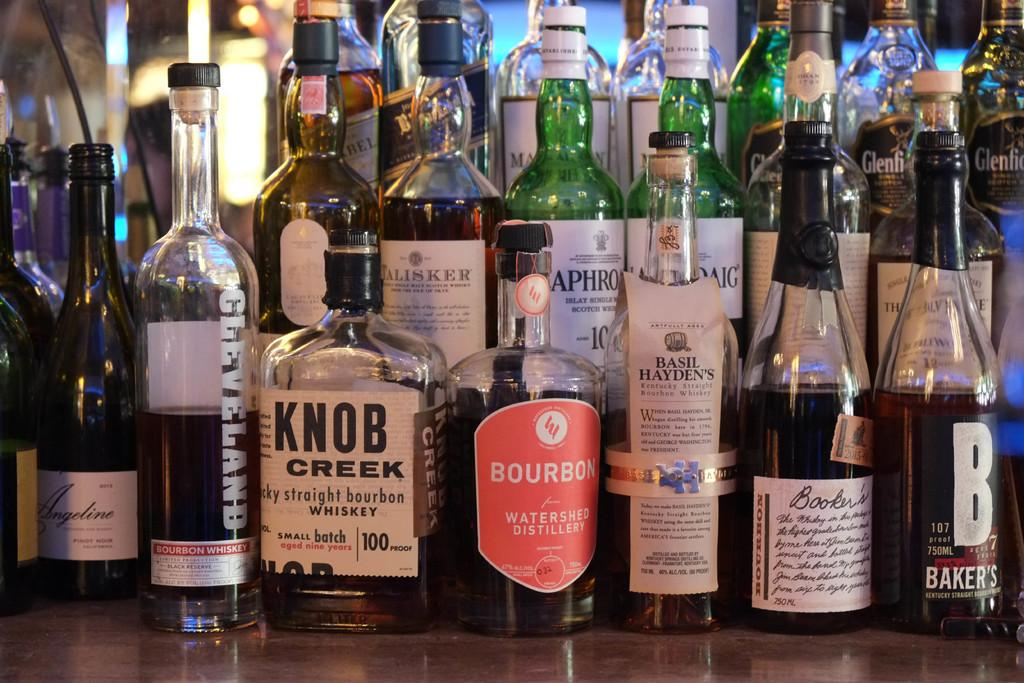<image>
Write a terse but informative summary of the picture. Several bottles of alcohol are arranged for display with one being called knob creek towards the front of it. 